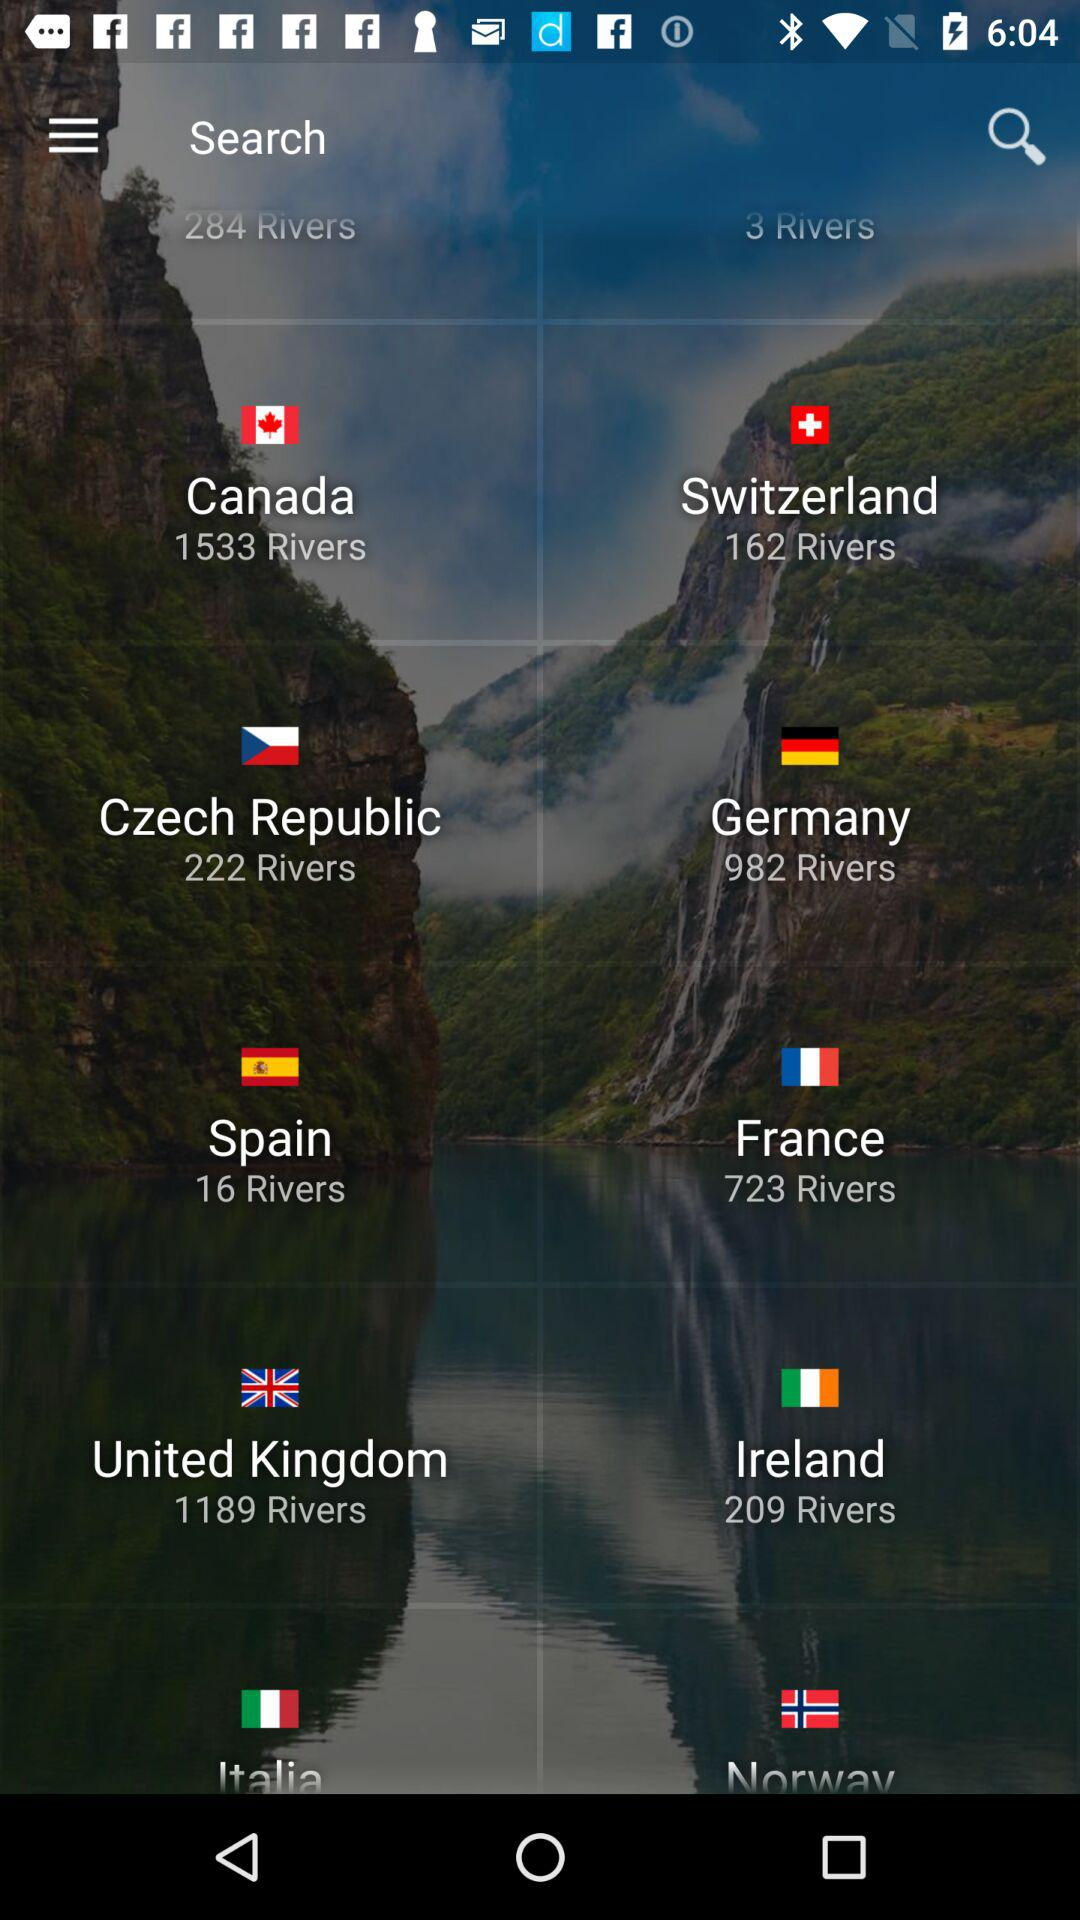How many rivers does Spain have? Spain has 16 rivers. 